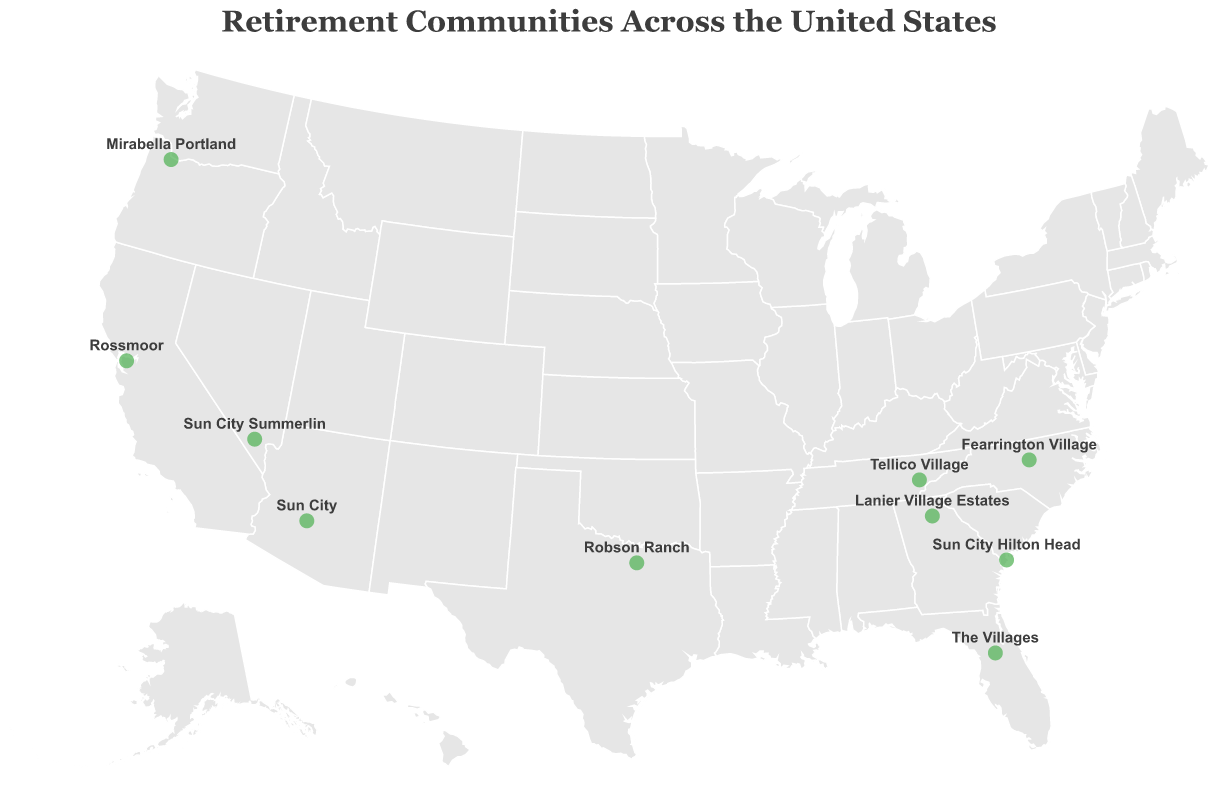What is the top amenity of the community in Tennessee? Locate the community in Tennessee on the map, which is Tellico Village. According to the tooltip information, the top amenity is "Lake Access."
Answer: Lake Access Which community in California has the highest cost rating? Find the community located in California on the map, which is Rossmoor. The tooltip shows that this community has a cost rating of 5, which is the highest in the dataset.
Answer: Rossmoor How many communities have a cost rating of 4? By looking at the tooltips of each community, count the number of communities with a cost rating of 4. The communities with a cost rating of 4 are The Villages, Sun City Hilton Head, and Mirabella Portland.
Answer: 3 Which community in Florida has a country music venue, and what is its name? Find the community in Florida on the map, which is The Villages. The tooltip information shows that the country music venue is "Savannah Center."
Answer: The Villages, Savannah Center Compare the top amenities of the communities in Nevada and Arizona. Locate the communities in Nevada and Arizona on the map, which are Sun City Summerlin in Nevada and Sun City in Arizona. According to the tooltip, Sun City Summerlin's top amenity is "Desert Views," and Sun City's top amenity is "Fitness Centers."
Answer: Desert Views (Nevada), Fitness Centers (Arizona) Which community has the lowest cost rating, and which top amenity does it offer? By examining the cost ratings in the tooltips, identify the lowest rating, which is 2. The communities with this rating are Robson Ranch in Texas and Lanier Village Estates in Georgia. Check their top amenities: Robson Ranch offers "Walking Trails," and Lanier Village Estates offers "Fishing Spots."
Answer: Robson Ranch (Walking Trails), Lanier Village Estates (Fishing Spots) Which state has the most retirement communities listed in the figure? Count the number of communities in each state based on the map and tooltips. Each state has only one community listed in the figure, so no state has more than one community.
Answer: Each state has one What is the average cost rating of all the listed retirement communities? Sum up all the cost ratings: 4 + 3 + 2 + 3 + 3 + 4 + 3 + 5 + 4 + 2 = 33. Divide this by the number of communities, which is 10. So, the average cost rating is 33/10.
Answer: 3.3 Is there any community with "Hiking Trails" as the top amenity? If yes, which state is it located in? Look through the tooltips to find "Hiking Trails" as the top amenity. Rossmoor in California offers "Hiking Trails."
Answer: Yes, California Which community is closest to the geographical center of the United States? Based on the map, the geographical center of the US is roughly in Kansas. The closest community on the map appears to be Robson Ranch in Texas.
Answer: Robson Ranch 